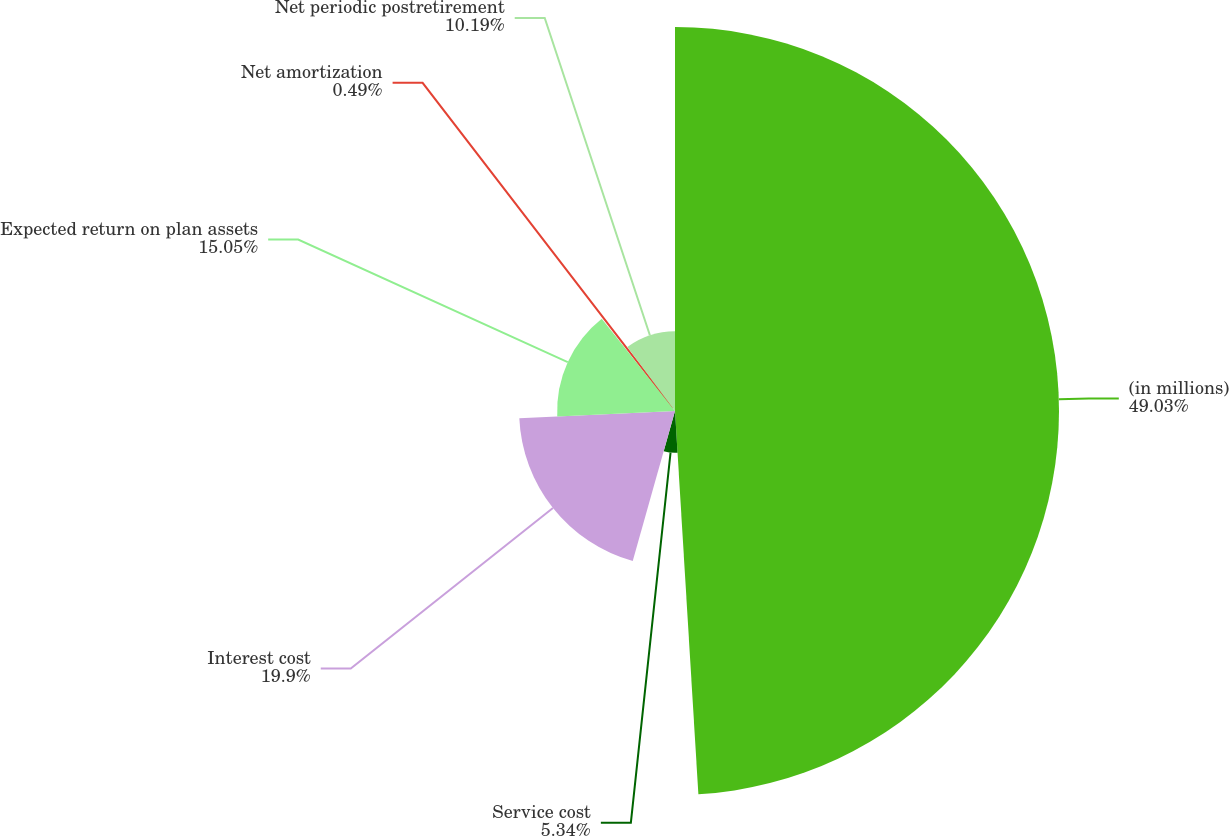<chart> <loc_0><loc_0><loc_500><loc_500><pie_chart><fcel>(in millions)<fcel>Service cost<fcel>Interest cost<fcel>Expected return on plan assets<fcel>Net amortization<fcel>Net periodic postretirement<nl><fcel>49.03%<fcel>5.34%<fcel>19.9%<fcel>15.05%<fcel>0.49%<fcel>10.19%<nl></chart> 